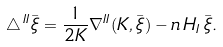Convert formula to latex. <formula><loc_0><loc_0><loc_500><loc_500>\triangle \, ^ { I I } \bar { \xi } = \frac { 1 } { 2 K } \nabla ^ { I I } ( K , \bar { \xi } ) - n \, H _ { I } \, \bar { \xi } .</formula> 